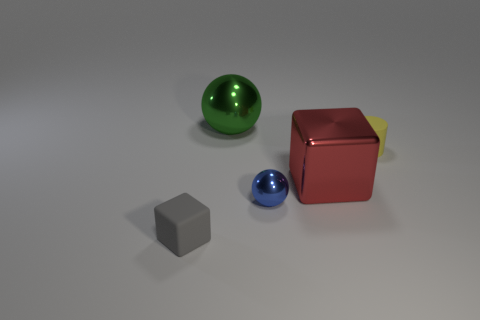What number of objects are in front of the rubber object that is right of the green object?
Your response must be concise. 3. The gray rubber thing is what shape?
Provide a short and direct response. Cube. The small gray object that is made of the same material as the yellow cylinder is what shape?
Offer a terse response. Cube. Does the rubber object behind the red block have the same shape as the big green thing?
Your response must be concise. No. The matte object in front of the small cylinder has what shape?
Give a very brief answer. Cube. What number of other matte things are the same size as the yellow matte object?
Ensure brevity in your answer.  1. The cylinder is what color?
Give a very brief answer. Yellow. Do the shiny block and the small object in front of the tiny ball have the same color?
Your response must be concise. No. The gray object that is made of the same material as the cylinder is what size?
Ensure brevity in your answer.  Small. Is there a big sphere that has the same color as the tiny cylinder?
Keep it short and to the point. No. 